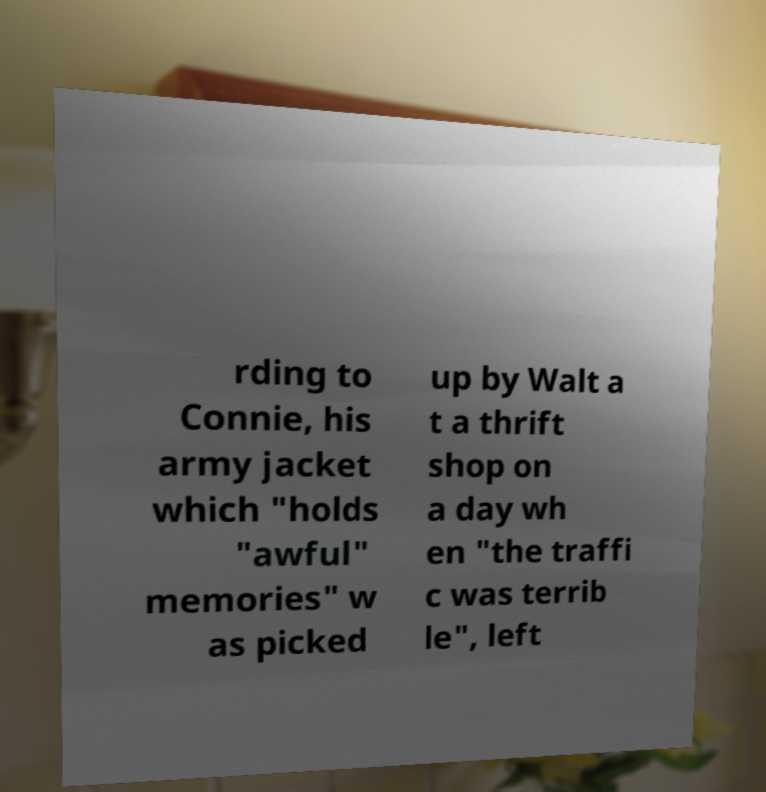Could you extract and type out the text from this image? rding to Connie, his army jacket which "holds "awful" memories" w as picked up by Walt a t a thrift shop on a day wh en "the traffi c was terrib le", left 